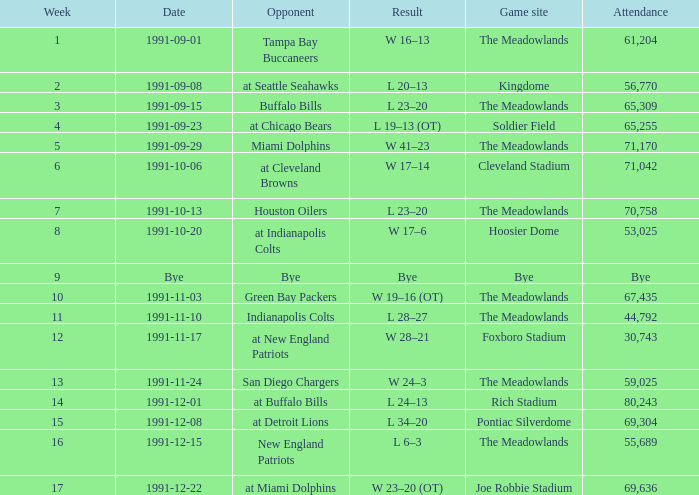What was the Attendance of the Game at Hoosier Dome? 53025.0. 